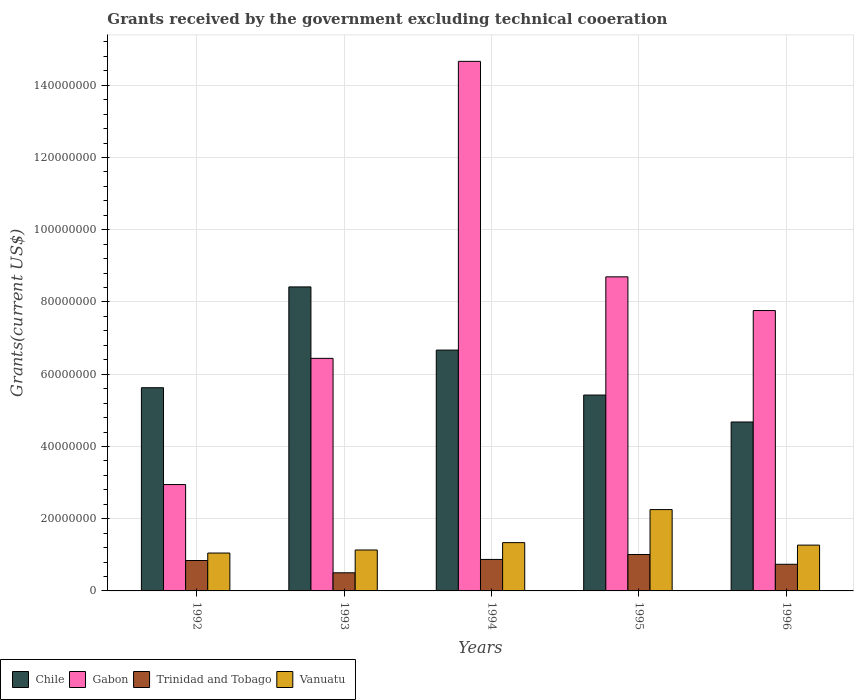How many different coloured bars are there?
Give a very brief answer. 4. What is the label of the 4th group of bars from the left?
Provide a succinct answer. 1995. What is the total grants received by the government in Chile in 1995?
Offer a very short reply. 5.42e+07. Across all years, what is the maximum total grants received by the government in Trinidad and Tobago?
Provide a succinct answer. 1.01e+07. Across all years, what is the minimum total grants received by the government in Trinidad and Tobago?
Your response must be concise. 5.02e+06. In which year was the total grants received by the government in Gabon maximum?
Keep it short and to the point. 1994. In which year was the total grants received by the government in Gabon minimum?
Provide a short and direct response. 1992. What is the total total grants received by the government in Vanuatu in the graph?
Your answer should be compact. 7.04e+07. What is the difference between the total grants received by the government in Chile in 1993 and that in 1996?
Offer a terse response. 3.74e+07. What is the difference between the total grants received by the government in Trinidad and Tobago in 1992 and the total grants received by the government in Chile in 1995?
Your answer should be compact. -4.58e+07. What is the average total grants received by the government in Chile per year?
Your answer should be very brief. 6.16e+07. In the year 1994, what is the difference between the total grants received by the government in Trinidad and Tobago and total grants received by the government in Vanuatu?
Provide a short and direct response. -4.65e+06. In how many years, is the total grants received by the government in Vanuatu greater than 124000000 US$?
Keep it short and to the point. 0. What is the ratio of the total grants received by the government in Gabon in 1995 to that in 1996?
Ensure brevity in your answer.  1.12. What is the difference between the highest and the second highest total grants received by the government in Gabon?
Make the answer very short. 5.97e+07. What is the difference between the highest and the lowest total grants received by the government in Trinidad and Tobago?
Offer a very short reply. 5.06e+06. Is it the case that in every year, the sum of the total grants received by the government in Chile and total grants received by the government in Gabon is greater than the sum of total grants received by the government in Vanuatu and total grants received by the government in Trinidad and Tobago?
Make the answer very short. Yes. What does the 2nd bar from the left in 1995 represents?
Your answer should be very brief. Gabon. What does the 3rd bar from the right in 1996 represents?
Provide a succinct answer. Gabon. Are all the bars in the graph horizontal?
Your answer should be very brief. No. What is the difference between two consecutive major ticks on the Y-axis?
Offer a terse response. 2.00e+07. Are the values on the major ticks of Y-axis written in scientific E-notation?
Offer a very short reply. No. Does the graph contain grids?
Give a very brief answer. Yes. How many legend labels are there?
Your response must be concise. 4. What is the title of the graph?
Provide a short and direct response. Grants received by the government excluding technical cooeration. Does "Greenland" appear as one of the legend labels in the graph?
Make the answer very short. No. What is the label or title of the X-axis?
Offer a very short reply. Years. What is the label or title of the Y-axis?
Keep it short and to the point. Grants(current US$). What is the Grants(current US$) in Chile in 1992?
Make the answer very short. 5.63e+07. What is the Grants(current US$) of Gabon in 1992?
Ensure brevity in your answer.  2.94e+07. What is the Grants(current US$) of Trinidad and Tobago in 1992?
Ensure brevity in your answer.  8.42e+06. What is the Grants(current US$) in Vanuatu in 1992?
Offer a very short reply. 1.05e+07. What is the Grants(current US$) in Chile in 1993?
Give a very brief answer. 8.42e+07. What is the Grants(current US$) of Gabon in 1993?
Provide a short and direct response. 6.44e+07. What is the Grants(current US$) in Trinidad and Tobago in 1993?
Ensure brevity in your answer.  5.02e+06. What is the Grants(current US$) in Vanuatu in 1993?
Offer a very short reply. 1.13e+07. What is the Grants(current US$) in Chile in 1994?
Keep it short and to the point. 6.67e+07. What is the Grants(current US$) in Gabon in 1994?
Provide a short and direct response. 1.47e+08. What is the Grants(current US$) of Trinidad and Tobago in 1994?
Keep it short and to the point. 8.72e+06. What is the Grants(current US$) in Vanuatu in 1994?
Offer a terse response. 1.34e+07. What is the Grants(current US$) in Chile in 1995?
Give a very brief answer. 5.42e+07. What is the Grants(current US$) in Gabon in 1995?
Ensure brevity in your answer.  8.70e+07. What is the Grants(current US$) of Trinidad and Tobago in 1995?
Your answer should be very brief. 1.01e+07. What is the Grants(current US$) of Vanuatu in 1995?
Provide a short and direct response. 2.25e+07. What is the Grants(current US$) of Chile in 1996?
Provide a succinct answer. 4.68e+07. What is the Grants(current US$) in Gabon in 1996?
Make the answer very short. 7.76e+07. What is the Grants(current US$) of Trinidad and Tobago in 1996?
Ensure brevity in your answer.  7.38e+06. What is the Grants(current US$) of Vanuatu in 1996?
Your answer should be very brief. 1.27e+07. Across all years, what is the maximum Grants(current US$) in Chile?
Make the answer very short. 8.42e+07. Across all years, what is the maximum Grants(current US$) of Gabon?
Your answer should be compact. 1.47e+08. Across all years, what is the maximum Grants(current US$) in Trinidad and Tobago?
Offer a terse response. 1.01e+07. Across all years, what is the maximum Grants(current US$) in Vanuatu?
Your answer should be very brief. 2.25e+07. Across all years, what is the minimum Grants(current US$) in Chile?
Offer a very short reply. 4.68e+07. Across all years, what is the minimum Grants(current US$) of Gabon?
Ensure brevity in your answer.  2.94e+07. Across all years, what is the minimum Grants(current US$) of Trinidad and Tobago?
Keep it short and to the point. 5.02e+06. Across all years, what is the minimum Grants(current US$) of Vanuatu?
Offer a very short reply. 1.05e+07. What is the total Grants(current US$) in Chile in the graph?
Your answer should be very brief. 3.08e+08. What is the total Grants(current US$) in Gabon in the graph?
Ensure brevity in your answer.  4.05e+08. What is the total Grants(current US$) in Trinidad and Tobago in the graph?
Offer a very short reply. 3.96e+07. What is the total Grants(current US$) of Vanuatu in the graph?
Your answer should be very brief. 7.04e+07. What is the difference between the Grants(current US$) in Chile in 1992 and that in 1993?
Provide a succinct answer. -2.79e+07. What is the difference between the Grants(current US$) in Gabon in 1992 and that in 1993?
Give a very brief answer. -3.49e+07. What is the difference between the Grants(current US$) of Trinidad and Tobago in 1992 and that in 1993?
Offer a very short reply. 3.40e+06. What is the difference between the Grants(current US$) of Vanuatu in 1992 and that in 1993?
Keep it short and to the point. -8.40e+05. What is the difference between the Grants(current US$) of Chile in 1992 and that in 1994?
Your answer should be very brief. -1.04e+07. What is the difference between the Grants(current US$) of Gabon in 1992 and that in 1994?
Offer a very short reply. -1.17e+08. What is the difference between the Grants(current US$) in Trinidad and Tobago in 1992 and that in 1994?
Make the answer very short. -3.00e+05. What is the difference between the Grants(current US$) of Vanuatu in 1992 and that in 1994?
Provide a succinct answer. -2.88e+06. What is the difference between the Grants(current US$) of Chile in 1992 and that in 1995?
Make the answer very short. 2.03e+06. What is the difference between the Grants(current US$) in Gabon in 1992 and that in 1995?
Keep it short and to the point. -5.75e+07. What is the difference between the Grants(current US$) in Trinidad and Tobago in 1992 and that in 1995?
Make the answer very short. -1.66e+06. What is the difference between the Grants(current US$) of Vanuatu in 1992 and that in 1995?
Your response must be concise. -1.20e+07. What is the difference between the Grants(current US$) of Chile in 1992 and that in 1996?
Offer a terse response. 9.49e+06. What is the difference between the Grants(current US$) in Gabon in 1992 and that in 1996?
Your answer should be compact. -4.82e+07. What is the difference between the Grants(current US$) of Trinidad and Tobago in 1992 and that in 1996?
Make the answer very short. 1.04e+06. What is the difference between the Grants(current US$) in Vanuatu in 1992 and that in 1996?
Provide a short and direct response. -2.19e+06. What is the difference between the Grants(current US$) of Chile in 1993 and that in 1994?
Offer a terse response. 1.75e+07. What is the difference between the Grants(current US$) in Gabon in 1993 and that in 1994?
Give a very brief answer. -8.22e+07. What is the difference between the Grants(current US$) in Trinidad and Tobago in 1993 and that in 1994?
Your answer should be compact. -3.70e+06. What is the difference between the Grants(current US$) of Vanuatu in 1993 and that in 1994?
Make the answer very short. -2.04e+06. What is the difference between the Grants(current US$) in Chile in 1993 and that in 1995?
Offer a terse response. 2.99e+07. What is the difference between the Grants(current US$) of Gabon in 1993 and that in 1995?
Offer a very short reply. -2.26e+07. What is the difference between the Grants(current US$) of Trinidad and Tobago in 1993 and that in 1995?
Give a very brief answer. -5.06e+06. What is the difference between the Grants(current US$) in Vanuatu in 1993 and that in 1995?
Keep it short and to the point. -1.12e+07. What is the difference between the Grants(current US$) of Chile in 1993 and that in 1996?
Your response must be concise. 3.74e+07. What is the difference between the Grants(current US$) of Gabon in 1993 and that in 1996?
Offer a terse response. -1.32e+07. What is the difference between the Grants(current US$) of Trinidad and Tobago in 1993 and that in 1996?
Provide a succinct answer. -2.36e+06. What is the difference between the Grants(current US$) of Vanuatu in 1993 and that in 1996?
Make the answer very short. -1.35e+06. What is the difference between the Grants(current US$) of Chile in 1994 and that in 1995?
Provide a succinct answer. 1.24e+07. What is the difference between the Grants(current US$) in Gabon in 1994 and that in 1995?
Provide a succinct answer. 5.97e+07. What is the difference between the Grants(current US$) in Trinidad and Tobago in 1994 and that in 1995?
Your response must be concise. -1.36e+06. What is the difference between the Grants(current US$) in Vanuatu in 1994 and that in 1995?
Your response must be concise. -9.15e+06. What is the difference between the Grants(current US$) of Chile in 1994 and that in 1996?
Your response must be concise. 1.99e+07. What is the difference between the Grants(current US$) in Gabon in 1994 and that in 1996?
Make the answer very short. 6.90e+07. What is the difference between the Grants(current US$) of Trinidad and Tobago in 1994 and that in 1996?
Your answer should be compact. 1.34e+06. What is the difference between the Grants(current US$) of Vanuatu in 1994 and that in 1996?
Your response must be concise. 6.90e+05. What is the difference between the Grants(current US$) of Chile in 1995 and that in 1996?
Ensure brevity in your answer.  7.46e+06. What is the difference between the Grants(current US$) of Gabon in 1995 and that in 1996?
Keep it short and to the point. 9.33e+06. What is the difference between the Grants(current US$) of Trinidad and Tobago in 1995 and that in 1996?
Give a very brief answer. 2.70e+06. What is the difference between the Grants(current US$) of Vanuatu in 1995 and that in 1996?
Offer a very short reply. 9.84e+06. What is the difference between the Grants(current US$) of Chile in 1992 and the Grants(current US$) of Gabon in 1993?
Make the answer very short. -8.13e+06. What is the difference between the Grants(current US$) of Chile in 1992 and the Grants(current US$) of Trinidad and Tobago in 1993?
Your response must be concise. 5.12e+07. What is the difference between the Grants(current US$) of Chile in 1992 and the Grants(current US$) of Vanuatu in 1993?
Provide a short and direct response. 4.49e+07. What is the difference between the Grants(current US$) of Gabon in 1992 and the Grants(current US$) of Trinidad and Tobago in 1993?
Your answer should be very brief. 2.44e+07. What is the difference between the Grants(current US$) in Gabon in 1992 and the Grants(current US$) in Vanuatu in 1993?
Make the answer very short. 1.81e+07. What is the difference between the Grants(current US$) of Trinidad and Tobago in 1992 and the Grants(current US$) of Vanuatu in 1993?
Your response must be concise. -2.91e+06. What is the difference between the Grants(current US$) in Chile in 1992 and the Grants(current US$) in Gabon in 1994?
Make the answer very short. -9.04e+07. What is the difference between the Grants(current US$) in Chile in 1992 and the Grants(current US$) in Trinidad and Tobago in 1994?
Make the answer very short. 4.75e+07. What is the difference between the Grants(current US$) in Chile in 1992 and the Grants(current US$) in Vanuatu in 1994?
Make the answer very short. 4.29e+07. What is the difference between the Grants(current US$) of Gabon in 1992 and the Grants(current US$) of Trinidad and Tobago in 1994?
Provide a short and direct response. 2.07e+07. What is the difference between the Grants(current US$) in Gabon in 1992 and the Grants(current US$) in Vanuatu in 1994?
Offer a very short reply. 1.61e+07. What is the difference between the Grants(current US$) in Trinidad and Tobago in 1992 and the Grants(current US$) in Vanuatu in 1994?
Make the answer very short. -4.95e+06. What is the difference between the Grants(current US$) in Chile in 1992 and the Grants(current US$) in Gabon in 1995?
Your response must be concise. -3.07e+07. What is the difference between the Grants(current US$) of Chile in 1992 and the Grants(current US$) of Trinidad and Tobago in 1995?
Make the answer very short. 4.62e+07. What is the difference between the Grants(current US$) of Chile in 1992 and the Grants(current US$) of Vanuatu in 1995?
Give a very brief answer. 3.37e+07. What is the difference between the Grants(current US$) of Gabon in 1992 and the Grants(current US$) of Trinidad and Tobago in 1995?
Your answer should be compact. 1.94e+07. What is the difference between the Grants(current US$) of Gabon in 1992 and the Grants(current US$) of Vanuatu in 1995?
Give a very brief answer. 6.93e+06. What is the difference between the Grants(current US$) of Trinidad and Tobago in 1992 and the Grants(current US$) of Vanuatu in 1995?
Your response must be concise. -1.41e+07. What is the difference between the Grants(current US$) in Chile in 1992 and the Grants(current US$) in Gabon in 1996?
Offer a terse response. -2.14e+07. What is the difference between the Grants(current US$) of Chile in 1992 and the Grants(current US$) of Trinidad and Tobago in 1996?
Provide a short and direct response. 4.89e+07. What is the difference between the Grants(current US$) of Chile in 1992 and the Grants(current US$) of Vanuatu in 1996?
Provide a short and direct response. 4.36e+07. What is the difference between the Grants(current US$) in Gabon in 1992 and the Grants(current US$) in Trinidad and Tobago in 1996?
Make the answer very short. 2.21e+07. What is the difference between the Grants(current US$) in Gabon in 1992 and the Grants(current US$) in Vanuatu in 1996?
Your answer should be compact. 1.68e+07. What is the difference between the Grants(current US$) in Trinidad and Tobago in 1992 and the Grants(current US$) in Vanuatu in 1996?
Provide a short and direct response. -4.26e+06. What is the difference between the Grants(current US$) of Chile in 1993 and the Grants(current US$) of Gabon in 1994?
Keep it short and to the point. -6.24e+07. What is the difference between the Grants(current US$) of Chile in 1993 and the Grants(current US$) of Trinidad and Tobago in 1994?
Offer a very short reply. 7.54e+07. What is the difference between the Grants(current US$) of Chile in 1993 and the Grants(current US$) of Vanuatu in 1994?
Provide a succinct answer. 7.08e+07. What is the difference between the Grants(current US$) in Gabon in 1993 and the Grants(current US$) in Trinidad and Tobago in 1994?
Provide a succinct answer. 5.57e+07. What is the difference between the Grants(current US$) in Gabon in 1993 and the Grants(current US$) in Vanuatu in 1994?
Your answer should be compact. 5.10e+07. What is the difference between the Grants(current US$) of Trinidad and Tobago in 1993 and the Grants(current US$) of Vanuatu in 1994?
Give a very brief answer. -8.35e+06. What is the difference between the Grants(current US$) of Chile in 1993 and the Grants(current US$) of Gabon in 1995?
Offer a terse response. -2.79e+06. What is the difference between the Grants(current US$) of Chile in 1993 and the Grants(current US$) of Trinidad and Tobago in 1995?
Your response must be concise. 7.41e+07. What is the difference between the Grants(current US$) in Chile in 1993 and the Grants(current US$) in Vanuatu in 1995?
Ensure brevity in your answer.  6.16e+07. What is the difference between the Grants(current US$) of Gabon in 1993 and the Grants(current US$) of Trinidad and Tobago in 1995?
Your answer should be very brief. 5.43e+07. What is the difference between the Grants(current US$) in Gabon in 1993 and the Grants(current US$) in Vanuatu in 1995?
Offer a terse response. 4.19e+07. What is the difference between the Grants(current US$) in Trinidad and Tobago in 1993 and the Grants(current US$) in Vanuatu in 1995?
Provide a succinct answer. -1.75e+07. What is the difference between the Grants(current US$) of Chile in 1993 and the Grants(current US$) of Gabon in 1996?
Provide a succinct answer. 6.54e+06. What is the difference between the Grants(current US$) of Chile in 1993 and the Grants(current US$) of Trinidad and Tobago in 1996?
Your answer should be compact. 7.68e+07. What is the difference between the Grants(current US$) of Chile in 1993 and the Grants(current US$) of Vanuatu in 1996?
Offer a very short reply. 7.15e+07. What is the difference between the Grants(current US$) of Gabon in 1993 and the Grants(current US$) of Trinidad and Tobago in 1996?
Your answer should be compact. 5.70e+07. What is the difference between the Grants(current US$) of Gabon in 1993 and the Grants(current US$) of Vanuatu in 1996?
Your answer should be compact. 5.17e+07. What is the difference between the Grants(current US$) in Trinidad and Tobago in 1993 and the Grants(current US$) in Vanuatu in 1996?
Your response must be concise. -7.66e+06. What is the difference between the Grants(current US$) of Chile in 1994 and the Grants(current US$) of Gabon in 1995?
Your answer should be very brief. -2.03e+07. What is the difference between the Grants(current US$) of Chile in 1994 and the Grants(current US$) of Trinidad and Tobago in 1995?
Your answer should be compact. 5.66e+07. What is the difference between the Grants(current US$) in Chile in 1994 and the Grants(current US$) in Vanuatu in 1995?
Your answer should be compact. 4.42e+07. What is the difference between the Grants(current US$) in Gabon in 1994 and the Grants(current US$) in Trinidad and Tobago in 1995?
Offer a terse response. 1.37e+08. What is the difference between the Grants(current US$) of Gabon in 1994 and the Grants(current US$) of Vanuatu in 1995?
Provide a short and direct response. 1.24e+08. What is the difference between the Grants(current US$) in Trinidad and Tobago in 1994 and the Grants(current US$) in Vanuatu in 1995?
Give a very brief answer. -1.38e+07. What is the difference between the Grants(current US$) of Chile in 1994 and the Grants(current US$) of Gabon in 1996?
Offer a very short reply. -1.10e+07. What is the difference between the Grants(current US$) in Chile in 1994 and the Grants(current US$) in Trinidad and Tobago in 1996?
Provide a succinct answer. 5.93e+07. What is the difference between the Grants(current US$) in Chile in 1994 and the Grants(current US$) in Vanuatu in 1996?
Your answer should be very brief. 5.40e+07. What is the difference between the Grants(current US$) in Gabon in 1994 and the Grants(current US$) in Trinidad and Tobago in 1996?
Make the answer very short. 1.39e+08. What is the difference between the Grants(current US$) of Gabon in 1994 and the Grants(current US$) of Vanuatu in 1996?
Your answer should be compact. 1.34e+08. What is the difference between the Grants(current US$) in Trinidad and Tobago in 1994 and the Grants(current US$) in Vanuatu in 1996?
Give a very brief answer. -3.96e+06. What is the difference between the Grants(current US$) in Chile in 1995 and the Grants(current US$) in Gabon in 1996?
Your answer should be very brief. -2.34e+07. What is the difference between the Grants(current US$) in Chile in 1995 and the Grants(current US$) in Trinidad and Tobago in 1996?
Offer a terse response. 4.68e+07. What is the difference between the Grants(current US$) of Chile in 1995 and the Grants(current US$) of Vanuatu in 1996?
Give a very brief answer. 4.16e+07. What is the difference between the Grants(current US$) in Gabon in 1995 and the Grants(current US$) in Trinidad and Tobago in 1996?
Provide a succinct answer. 7.96e+07. What is the difference between the Grants(current US$) of Gabon in 1995 and the Grants(current US$) of Vanuatu in 1996?
Your answer should be very brief. 7.43e+07. What is the difference between the Grants(current US$) in Trinidad and Tobago in 1995 and the Grants(current US$) in Vanuatu in 1996?
Make the answer very short. -2.60e+06. What is the average Grants(current US$) in Chile per year?
Ensure brevity in your answer.  6.16e+07. What is the average Grants(current US$) in Gabon per year?
Provide a short and direct response. 8.10e+07. What is the average Grants(current US$) in Trinidad and Tobago per year?
Your answer should be very brief. 7.92e+06. What is the average Grants(current US$) of Vanuatu per year?
Provide a succinct answer. 1.41e+07. In the year 1992, what is the difference between the Grants(current US$) of Chile and Grants(current US$) of Gabon?
Offer a terse response. 2.68e+07. In the year 1992, what is the difference between the Grants(current US$) in Chile and Grants(current US$) in Trinidad and Tobago?
Provide a short and direct response. 4.78e+07. In the year 1992, what is the difference between the Grants(current US$) of Chile and Grants(current US$) of Vanuatu?
Provide a short and direct response. 4.58e+07. In the year 1992, what is the difference between the Grants(current US$) of Gabon and Grants(current US$) of Trinidad and Tobago?
Your answer should be compact. 2.10e+07. In the year 1992, what is the difference between the Grants(current US$) in Gabon and Grants(current US$) in Vanuatu?
Keep it short and to the point. 1.90e+07. In the year 1992, what is the difference between the Grants(current US$) in Trinidad and Tobago and Grants(current US$) in Vanuatu?
Give a very brief answer. -2.07e+06. In the year 1993, what is the difference between the Grants(current US$) in Chile and Grants(current US$) in Gabon?
Provide a short and direct response. 1.98e+07. In the year 1993, what is the difference between the Grants(current US$) in Chile and Grants(current US$) in Trinidad and Tobago?
Your answer should be compact. 7.92e+07. In the year 1993, what is the difference between the Grants(current US$) in Chile and Grants(current US$) in Vanuatu?
Your response must be concise. 7.28e+07. In the year 1993, what is the difference between the Grants(current US$) of Gabon and Grants(current US$) of Trinidad and Tobago?
Ensure brevity in your answer.  5.94e+07. In the year 1993, what is the difference between the Grants(current US$) of Gabon and Grants(current US$) of Vanuatu?
Keep it short and to the point. 5.31e+07. In the year 1993, what is the difference between the Grants(current US$) in Trinidad and Tobago and Grants(current US$) in Vanuatu?
Offer a terse response. -6.31e+06. In the year 1994, what is the difference between the Grants(current US$) in Chile and Grants(current US$) in Gabon?
Offer a terse response. -7.99e+07. In the year 1994, what is the difference between the Grants(current US$) of Chile and Grants(current US$) of Trinidad and Tobago?
Keep it short and to the point. 5.80e+07. In the year 1994, what is the difference between the Grants(current US$) of Chile and Grants(current US$) of Vanuatu?
Provide a succinct answer. 5.33e+07. In the year 1994, what is the difference between the Grants(current US$) of Gabon and Grants(current US$) of Trinidad and Tobago?
Provide a short and direct response. 1.38e+08. In the year 1994, what is the difference between the Grants(current US$) in Gabon and Grants(current US$) in Vanuatu?
Offer a very short reply. 1.33e+08. In the year 1994, what is the difference between the Grants(current US$) of Trinidad and Tobago and Grants(current US$) of Vanuatu?
Your response must be concise. -4.65e+06. In the year 1995, what is the difference between the Grants(current US$) in Chile and Grants(current US$) in Gabon?
Keep it short and to the point. -3.27e+07. In the year 1995, what is the difference between the Grants(current US$) in Chile and Grants(current US$) in Trinidad and Tobago?
Your response must be concise. 4.42e+07. In the year 1995, what is the difference between the Grants(current US$) in Chile and Grants(current US$) in Vanuatu?
Provide a succinct answer. 3.17e+07. In the year 1995, what is the difference between the Grants(current US$) in Gabon and Grants(current US$) in Trinidad and Tobago?
Your answer should be very brief. 7.69e+07. In the year 1995, what is the difference between the Grants(current US$) of Gabon and Grants(current US$) of Vanuatu?
Your answer should be compact. 6.44e+07. In the year 1995, what is the difference between the Grants(current US$) of Trinidad and Tobago and Grants(current US$) of Vanuatu?
Offer a terse response. -1.24e+07. In the year 1996, what is the difference between the Grants(current US$) of Chile and Grants(current US$) of Gabon?
Offer a very short reply. -3.09e+07. In the year 1996, what is the difference between the Grants(current US$) in Chile and Grants(current US$) in Trinidad and Tobago?
Your answer should be compact. 3.94e+07. In the year 1996, what is the difference between the Grants(current US$) in Chile and Grants(current US$) in Vanuatu?
Provide a succinct answer. 3.41e+07. In the year 1996, what is the difference between the Grants(current US$) in Gabon and Grants(current US$) in Trinidad and Tobago?
Your response must be concise. 7.02e+07. In the year 1996, what is the difference between the Grants(current US$) of Gabon and Grants(current US$) of Vanuatu?
Offer a terse response. 6.50e+07. In the year 1996, what is the difference between the Grants(current US$) in Trinidad and Tobago and Grants(current US$) in Vanuatu?
Your answer should be compact. -5.30e+06. What is the ratio of the Grants(current US$) in Chile in 1992 to that in 1993?
Keep it short and to the point. 0.67. What is the ratio of the Grants(current US$) in Gabon in 1992 to that in 1993?
Your answer should be very brief. 0.46. What is the ratio of the Grants(current US$) in Trinidad and Tobago in 1992 to that in 1993?
Offer a terse response. 1.68. What is the ratio of the Grants(current US$) in Vanuatu in 1992 to that in 1993?
Ensure brevity in your answer.  0.93. What is the ratio of the Grants(current US$) in Chile in 1992 to that in 1994?
Provide a short and direct response. 0.84. What is the ratio of the Grants(current US$) of Gabon in 1992 to that in 1994?
Make the answer very short. 0.2. What is the ratio of the Grants(current US$) in Trinidad and Tobago in 1992 to that in 1994?
Give a very brief answer. 0.97. What is the ratio of the Grants(current US$) of Vanuatu in 1992 to that in 1994?
Keep it short and to the point. 0.78. What is the ratio of the Grants(current US$) of Chile in 1992 to that in 1995?
Offer a very short reply. 1.04. What is the ratio of the Grants(current US$) of Gabon in 1992 to that in 1995?
Your response must be concise. 0.34. What is the ratio of the Grants(current US$) in Trinidad and Tobago in 1992 to that in 1995?
Your response must be concise. 0.84. What is the ratio of the Grants(current US$) of Vanuatu in 1992 to that in 1995?
Your answer should be very brief. 0.47. What is the ratio of the Grants(current US$) of Chile in 1992 to that in 1996?
Ensure brevity in your answer.  1.2. What is the ratio of the Grants(current US$) of Gabon in 1992 to that in 1996?
Make the answer very short. 0.38. What is the ratio of the Grants(current US$) in Trinidad and Tobago in 1992 to that in 1996?
Keep it short and to the point. 1.14. What is the ratio of the Grants(current US$) of Vanuatu in 1992 to that in 1996?
Ensure brevity in your answer.  0.83. What is the ratio of the Grants(current US$) in Chile in 1993 to that in 1994?
Your response must be concise. 1.26. What is the ratio of the Grants(current US$) of Gabon in 1993 to that in 1994?
Your answer should be compact. 0.44. What is the ratio of the Grants(current US$) in Trinidad and Tobago in 1993 to that in 1994?
Make the answer very short. 0.58. What is the ratio of the Grants(current US$) of Vanuatu in 1993 to that in 1994?
Your answer should be compact. 0.85. What is the ratio of the Grants(current US$) in Chile in 1993 to that in 1995?
Give a very brief answer. 1.55. What is the ratio of the Grants(current US$) of Gabon in 1993 to that in 1995?
Give a very brief answer. 0.74. What is the ratio of the Grants(current US$) of Trinidad and Tobago in 1993 to that in 1995?
Give a very brief answer. 0.5. What is the ratio of the Grants(current US$) in Vanuatu in 1993 to that in 1995?
Your answer should be compact. 0.5. What is the ratio of the Grants(current US$) in Chile in 1993 to that in 1996?
Your response must be concise. 1.8. What is the ratio of the Grants(current US$) of Gabon in 1993 to that in 1996?
Your answer should be very brief. 0.83. What is the ratio of the Grants(current US$) of Trinidad and Tobago in 1993 to that in 1996?
Offer a very short reply. 0.68. What is the ratio of the Grants(current US$) in Vanuatu in 1993 to that in 1996?
Give a very brief answer. 0.89. What is the ratio of the Grants(current US$) in Chile in 1994 to that in 1995?
Your response must be concise. 1.23. What is the ratio of the Grants(current US$) in Gabon in 1994 to that in 1995?
Make the answer very short. 1.69. What is the ratio of the Grants(current US$) of Trinidad and Tobago in 1994 to that in 1995?
Ensure brevity in your answer.  0.87. What is the ratio of the Grants(current US$) of Vanuatu in 1994 to that in 1995?
Offer a terse response. 0.59. What is the ratio of the Grants(current US$) of Chile in 1994 to that in 1996?
Give a very brief answer. 1.43. What is the ratio of the Grants(current US$) of Gabon in 1994 to that in 1996?
Your answer should be compact. 1.89. What is the ratio of the Grants(current US$) in Trinidad and Tobago in 1994 to that in 1996?
Make the answer very short. 1.18. What is the ratio of the Grants(current US$) of Vanuatu in 1994 to that in 1996?
Ensure brevity in your answer.  1.05. What is the ratio of the Grants(current US$) in Chile in 1995 to that in 1996?
Give a very brief answer. 1.16. What is the ratio of the Grants(current US$) in Gabon in 1995 to that in 1996?
Your response must be concise. 1.12. What is the ratio of the Grants(current US$) in Trinidad and Tobago in 1995 to that in 1996?
Offer a very short reply. 1.37. What is the ratio of the Grants(current US$) in Vanuatu in 1995 to that in 1996?
Make the answer very short. 1.78. What is the difference between the highest and the second highest Grants(current US$) of Chile?
Make the answer very short. 1.75e+07. What is the difference between the highest and the second highest Grants(current US$) in Gabon?
Your response must be concise. 5.97e+07. What is the difference between the highest and the second highest Grants(current US$) in Trinidad and Tobago?
Your answer should be very brief. 1.36e+06. What is the difference between the highest and the second highest Grants(current US$) in Vanuatu?
Give a very brief answer. 9.15e+06. What is the difference between the highest and the lowest Grants(current US$) in Chile?
Ensure brevity in your answer.  3.74e+07. What is the difference between the highest and the lowest Grants(current US$) of Gabon?
Offer a terse response. 1.17e+08. What is the difference between the highest and the lowest Grants(current US$) in Trinidad and Tobago?
Provide a succinct answer. 5.06e+06. What is the difference between the highest and the lowest Grants(current US$) of Vanuatu?
Provide a short and direct response. 1.20e+07. 